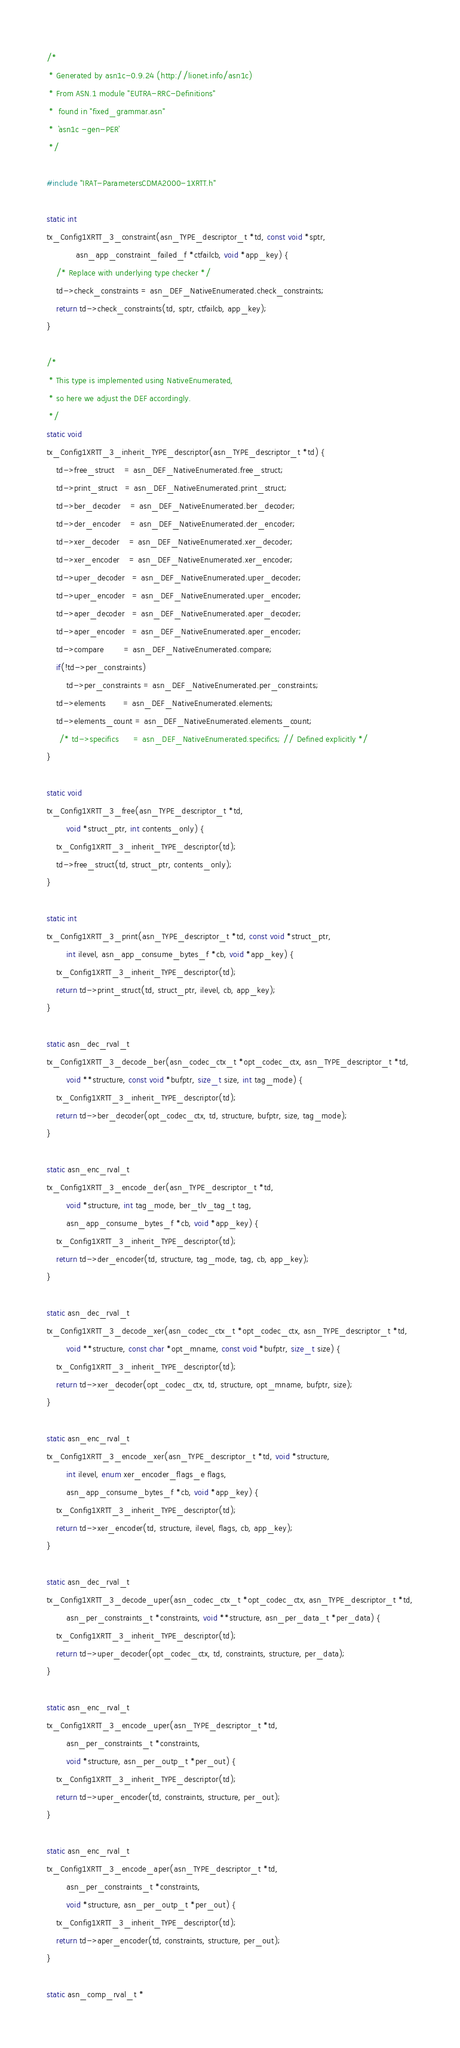<code> <loc_0><loc_0><loc_500><loc_500><_C_>/*
 * Generated by asn1c-0.9.24 (http://lionet.info/asn1c)
 * From ASN.1 module "EUTRA-RRC-Definitions"
 * 	found in "fixed_grammar.asn"
 * 	`asn1c -gen-PER`
 */

#include "IRAT-ParametersCDMA2000-1XRTT.h"

static int
tx_Config1XRTT_3_constraint(asn_TYPE_descriptor_t *td, const void *sptr,
			asn_app_constraint_failed_f *ctfailcb, void *app_key) {
	/* Replace with underlying type checker */
	td->check_constraints = asn_DEF_NativeEnumerated.check_constraints;
	return td->check_constraints(td, sptr, ctfailcb, app_key);
}

/*
 * This type is implemented using NativeEnumerated,
 * so here we adjust the DEF accordingly.
 */
static void
tx_Config1XRTT_3_inherit_TYPE_descriptor(asn_TYPE_descriptor_t *td) {
	td->free_struct    = asn_DEF_NativeEnumerated.free_struct;
	td->print_struct   = asn_DEF_NativeEnumerated.print_struct;
	td->ber_decoder    = asn_DEF_NativeEnumerated.ber_decoder;
	td->der_encoder    = asn_DEF_NativeEnumerated.der_encoder;
	td->xer_decoder    = asn_DEF_NativeEnumerated.xer_decoder;
	td->xer_encoder    = asn_DEF_NativeEnumerated.xer_encoder;
	td->uper_decoder   = asn_DEF_NativeEnumerated.uper_decoder;
	td->uper_encoder   = asn_DEF_NativeEnumerated.uper_encoder;
	td->aper_decoder   = asn_DEF_NativeEnumerated.aper_decoder;
	td->aper_encoder   = asn_DEF_NativeEnumerated.aper_encoder;
	td->compare        = asn_DEF_NativeEnumerated.compare;
	if(!td->per_constraints)
		td->per_constraints = asn_DEF_NativeEnumerated.per_constraints;
	td->elements       = asn_DEF_NativeEnumerated.elements;
	td->elements_count = asn_DEF_NativeEnumerated.elements_count;
     /* td->specifics      = asn_DEF_NativeEnumerated.specifics;	// Defined explicitly */
}

static void
tx_Config1XRTT_3_free(asn_TYPE_descriptor_t *td,
		void *struct_ptr, int contents_only) {
	tx_Config1XRTT_3_inherit_TYPE_descriptor(td);
	td->free_struct(td, struct_ptr, contents_only);
}

static int
tx_Config1XRTT_3_print(asn_TYPE_descriptor_t *td, const void *struct_ptr,
		int ilevel, asn_app_consume_bytes_f *cb, void *app_key) {
	tx_Config1XRTT_3_inherit_TYPE_descriptor(td);
	return td->print_struct(td, struct_ptr, ilevel, cb, app_key);
}

static asn_dec_rval_t
tx_Config1XRTT_3_decode_ber(asn_codec_ctx_t *opt_codec_ctx, asn_TYPE_descriptor_t *td,
		void **structure, const void *bufptr, size_t size, int tag_mode) {
	tx_Config1XRTT_3_inherit_TYPE_descriptor(td);
	return td->ber_decoder(opt_codec_ctx, td, structure, bufptr, size, tag_mode);
}

static asn_enc_rval_t
tx_Config1XRTT_3_encode_der(asn_TYPE_descriptor_t *td,
		void *structure, int tag_mode, ber_tlv_tag_t tag,
		asn_app_consume_bytes_f *cb, void *app_key) {
	tx_Config1XRTT_3_inherit_TYPE_descriptor(td);
	return td->der_encoder(td, structure, tag_mode, tag, cb, app_key);
}

static asn_dec_rval_t
tx_Config1XRTT_3_decode_xer(asn_codec_ctx_t *opt_codec_ctx, asn_TYPE_descriptor_t *td,
		void **structure, const char *opt_mname, const void *bufptr, size_t size) {
	tx_Config1XRTT_3_inherit_TYPE_descriptor(td);
	return td->xer_decoder(opt_codec_ctx, td, structure, opt_mname, bufptr, size);
}

static asn_enc_rval_t
tx_Config1XRTT_3_encode_xer(asn_TYPE_descriptor_t *td, void *structure,
		int ilevel, enum xer_encoder_flags_e flags,
		asn_app_consume_bytes_f *cb, void *app_key) {
	tx_Config1XRTT_3_inherit_TYPE_descriptor(td);
	return td->xer_encoder(td, structure, ilevel, flags, cb, app_key);
}

static asn_dec_rval_t
tx_Config1XRTT_3_decode_uper(asn_codec_ctx_t *opt_codec_ctx, asn_TYPE_descriptor_t *td,
		asn_per_constraints_t *constraints, void **structure, asn_per_data_t *per_data) {
	tx_Config1XRTT_3_inherit_TYPE_descriptor(td);
	return td->uper_decoder(opt_codec_ctx, td, constraints, structure, per_data);
}

static asn_enc_rval_t
tx_Config1XRTT_3_encode_uper(asn_TYPE_descriptor_t *td,
		asn_per_constraints_t *constraints,
		void *structure, asn_per_outp_t *per_out) {
	tx_Config1XRTT_3_inherit_TYPE_descriptor(td);
	return td->uper_encoder(td, constraints, structure, per_out);
}

static asn_enc_rval_t
tx_Config1XRTT_3_encode_aper(asn_TYPE_descriptor_t *td,
		asn_per_constraints_t *constraints,
		void *structure, asn_per_outp_t *per_out) {
	tx_Config1XRTT_3_inherit_TYPE_descriptor(td);
	return td->aper_encoder(td, constraints, structure, per_out);
}

static asn_comp_rval_t * </code> 